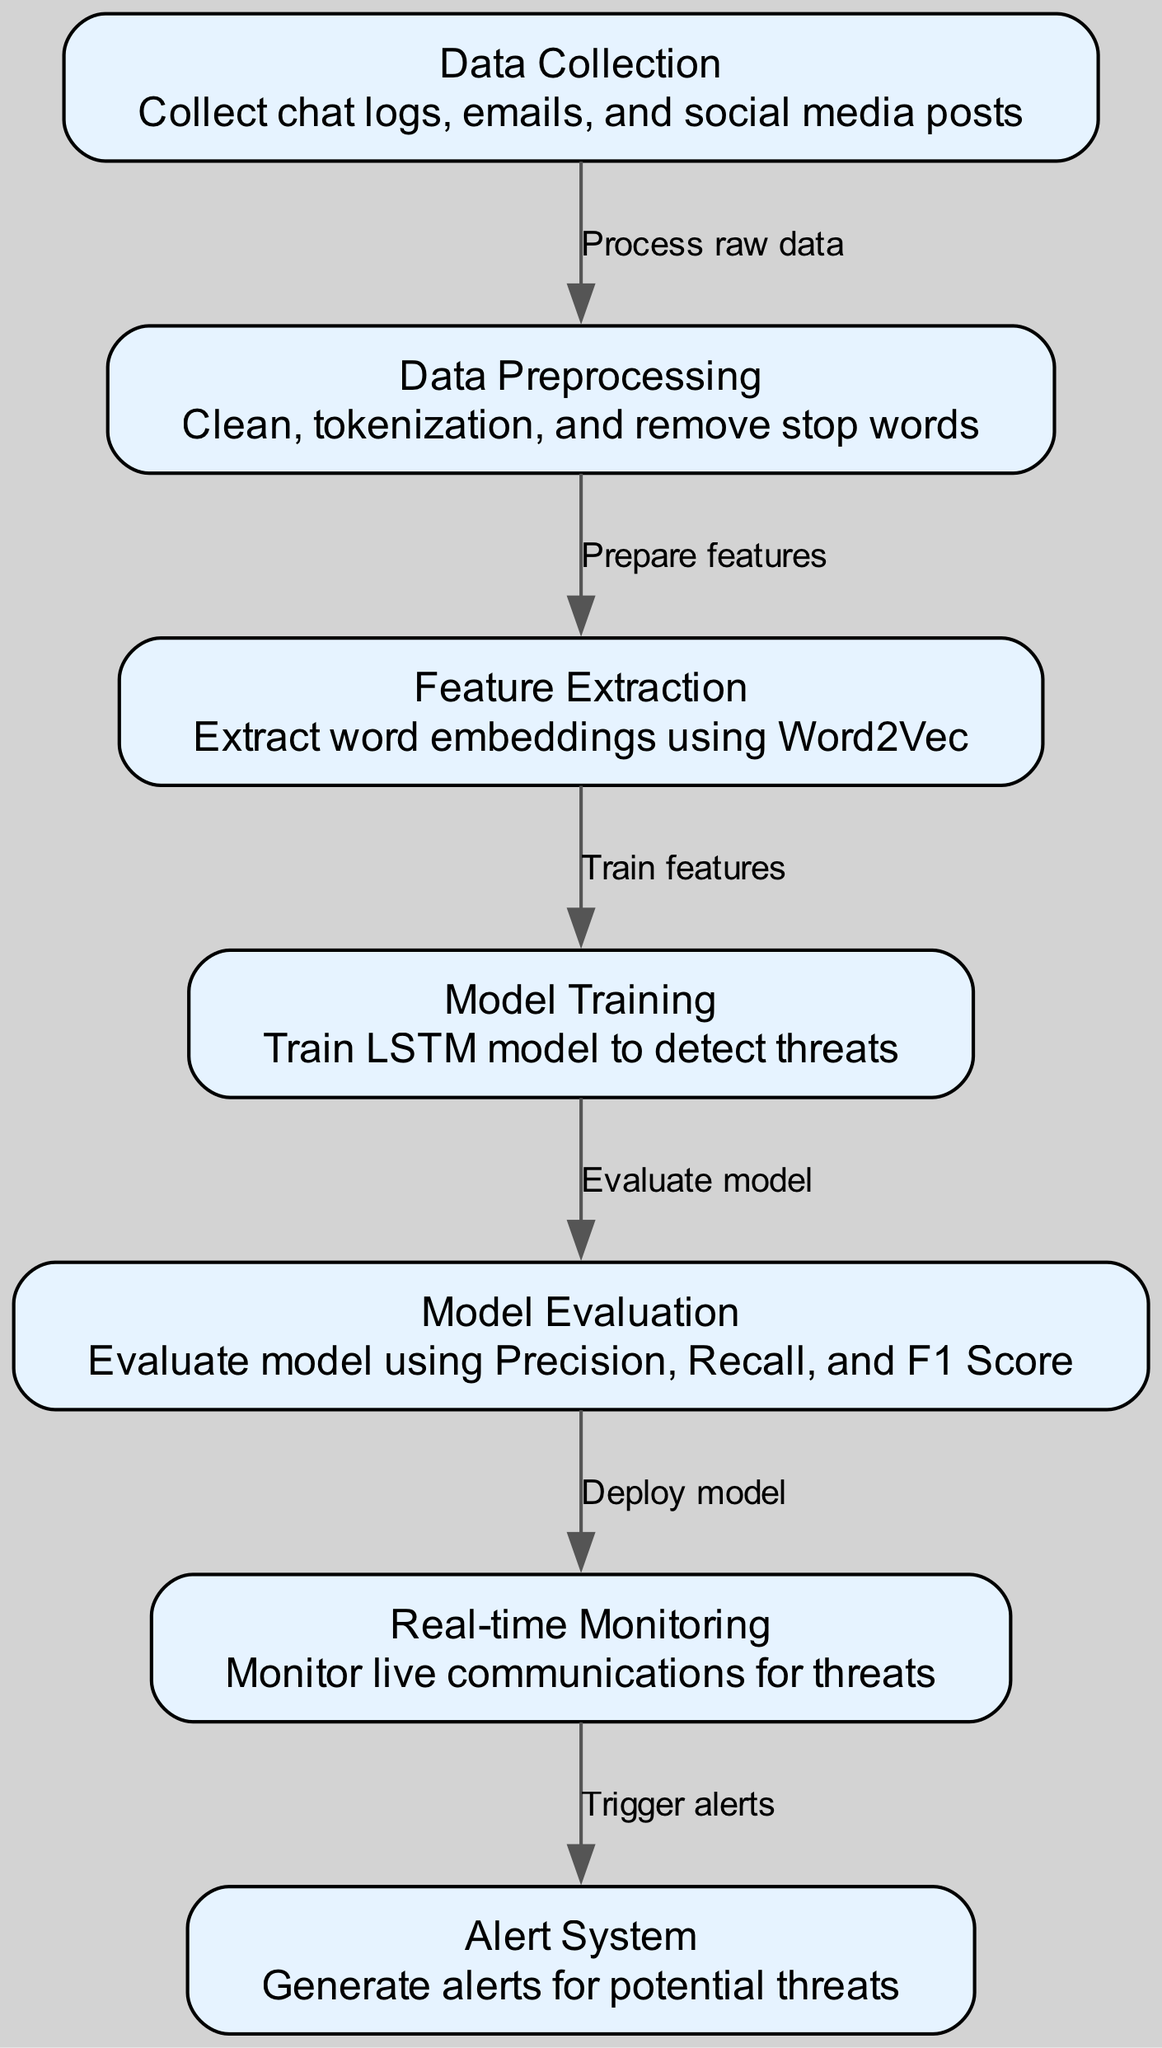What is the first step in the diagram? The diagram starts with the "Data Collection" node, which involves collecting chat logs, emails, and social media posts.
Answer: Data Collection How many nodes are present in the diagram? There are a total of 7 nodes represented in the diagram, covering various stages of the threat detection process.
Answer: 7 What follows "Data Preprocessing" in the flow? After "Data Preprocessing," the next step is "Feature Extraction," where word embeddings are extracted using Word2Vec.
Answer: Feature Extraction Which model is used for threat detection? The model used for threat detection in this diagram is the LSTM model, which is trained on the extracted features.
Answer: LSTM model What performance metrics are used for model evaluation? The model evaluation process utilizes Precision, Recall, and F1 Score to assess the performance of the LSTM model.
Answer: Precision, Recall, F1 Score How many edges connect the nodes in the diagram? There are 6 edges in the diagram, indicating the flow from one node to another.
Answer: 6 What triggers alerts in the system? The "Real-time Monitoring" node triggers alerts for potential threats, which is relayed to the "Alert System."
Answer: Real-time Monitoring What is the main purpose of the "Alert System"? The purpose of the "Alert System" is to generate alerts for potential threats detected during monitoring.
Answer: Generate alerts Which node follows "Model Evaluation"? The node that follows "Model Evaluation" is "Real-time Monitoring," indicating that the evaluated model is deployed for monitoring.
Answer: Real-time Monitoring 